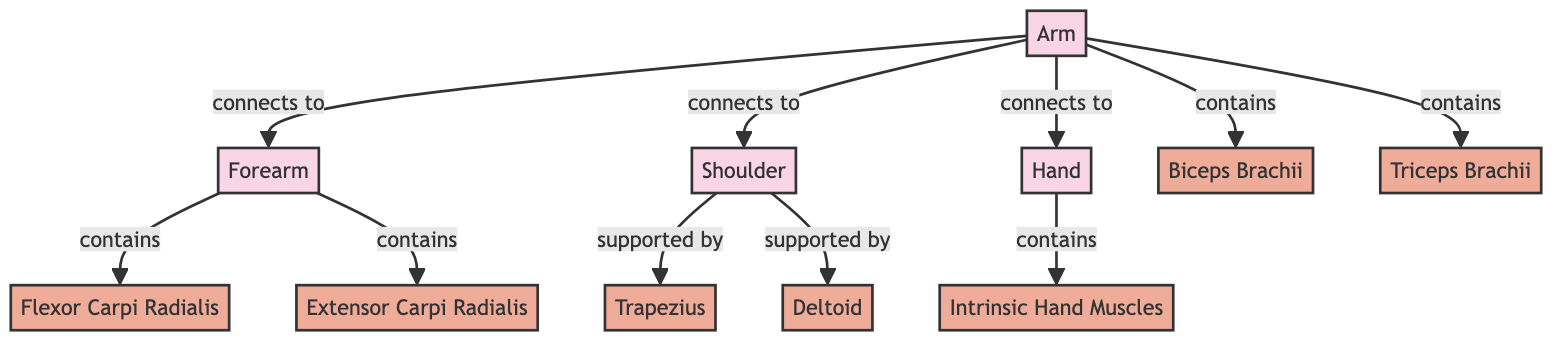What are the main body parts involved in artistic activities? The diagram lists four main body parts relevant to artistic activities, which are the Arm, Forearm, Shoulder, and Hand. These parts are the foundational elements that contribute to muscle movement during activities like painting and sculpting.
Answer: Arm, Forearm, Shoulder, Hand How many muscles are shown in relation to the Arm? The diagram depicts four muscles that are directly associated with the Arm: Biceps Brachii, Triceps Brachii, Deltoid, and the two trapezius muscles supporting the Shoulder. Counting all relevant connections, the total is determined.
Answer: Four Which muscle supports the Shoulder? The diagram indicates that the Shoulder is supported by two muscles: Trapezius and Deltoid. These muscles play crucial roles in stabilizing and moving the Shoulder during artistic tasks.
Answer: Trapezius, Deltoid What muscles are contained within the Forearm? Based on the diagram, the Forearm contains two specific muscles: Flexor Carpi Radialis and Extensor Carpi Radialis. These muscles are essential for wrist and finger movement, particularly in painting and sculpting.
Answer: Flexor Carpi Radialis, Extensor Carpi Radialis How is the Hand connected to the Arm in the diagram? The Hand is directly connected to the Arm, showing a clear pathway of movement from the Arm through the Hand, indicating that both parts work together during artistic activities. The relationship depicted is "connects to."
Answer: Connects to 